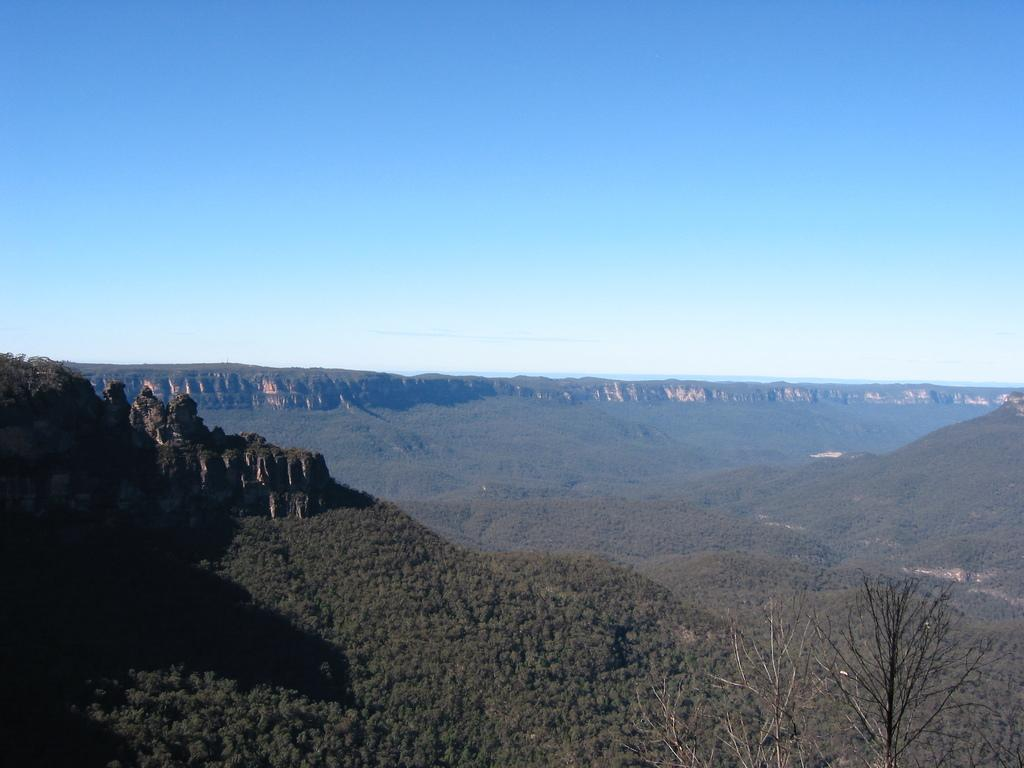What type of natural landform can be seen in the image? There are mountains in the image. What type of vegetation is present in the image? There are trees in the image. What part of the natural environment is visible in the image? The sky is visible in the image. What type of calculator can be seen in the image? There is no calculator present in the image. Is there a railway visible in the image? There is no railway present in the image. 